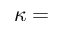<formula> <loc_0><loc_0><loc_500><loc_500>\kappa =</formula> 